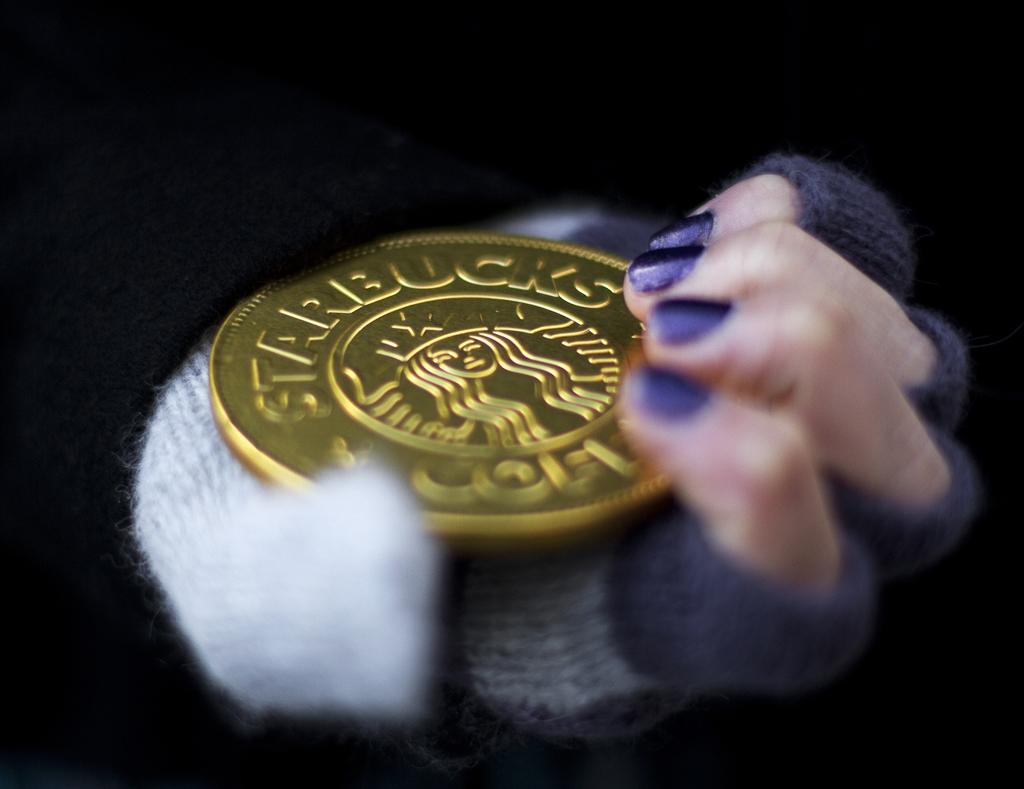What does the coin say?
Offer a terse response. Starbucks. 